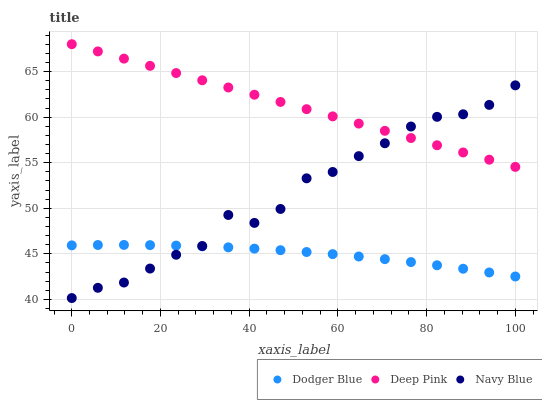Does Dodger Blue have the minimum area under the curve?
Answer yes or no. Yes. Does Deep Pink have the maximum area under the curve?
Answer yes or no. Yes. Does Deep Pink have the minimum area under the curve?
Answer yes or no. No. Does Dodger Blue have the maximum area under the curve?
Answer yes or no. No. Is Deep Pink the smoothest?
Answer yes or no. Yes. Is Navy Blue the roughest?
Answer yes or no. Yes. Is Dodger Blue the smoothest?
Answer yes or no. No. Is Dodger Blue the roughest?
Answer yes or no. No. Does Navy Blue have the lowest value?
Answer yes or no. Yes. Does Dodger Blue have the lowest value?
Answer yes or no. No. Does Deep Pink have the highest value?
Answer yes or no. Yes. Does Dodger Blue have the highest value?
Answer yes or no. No. Is Dodger Blue less than Deep Pink?
Answer yes or no. Yes. Is Deep Pink greater than Dodger Blue?
Answer yes or no. Yes. Does Navy Blue intersect Deep Pink?
Answer yes or no. Yes. Is Navy Blue less than Deep Pink?
Answer yes or no. No. Is Navy Blue greater than Deep Pink?
Answer yes or no. No. Does Dodger Blue intersect Deep Pink?
Answer yes or no. No. 